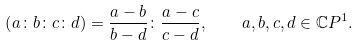<formula> <loc_0><loc_0><loc_500><loc_500>\left ( a \colon b \colon c \colon d \right ) = \frac { a - b } { b - d } \colon \frac { a - c } { c - d } , \quad a , b , c , d \in { \mathbb { C } } P ^ { 1 } .</formula> 